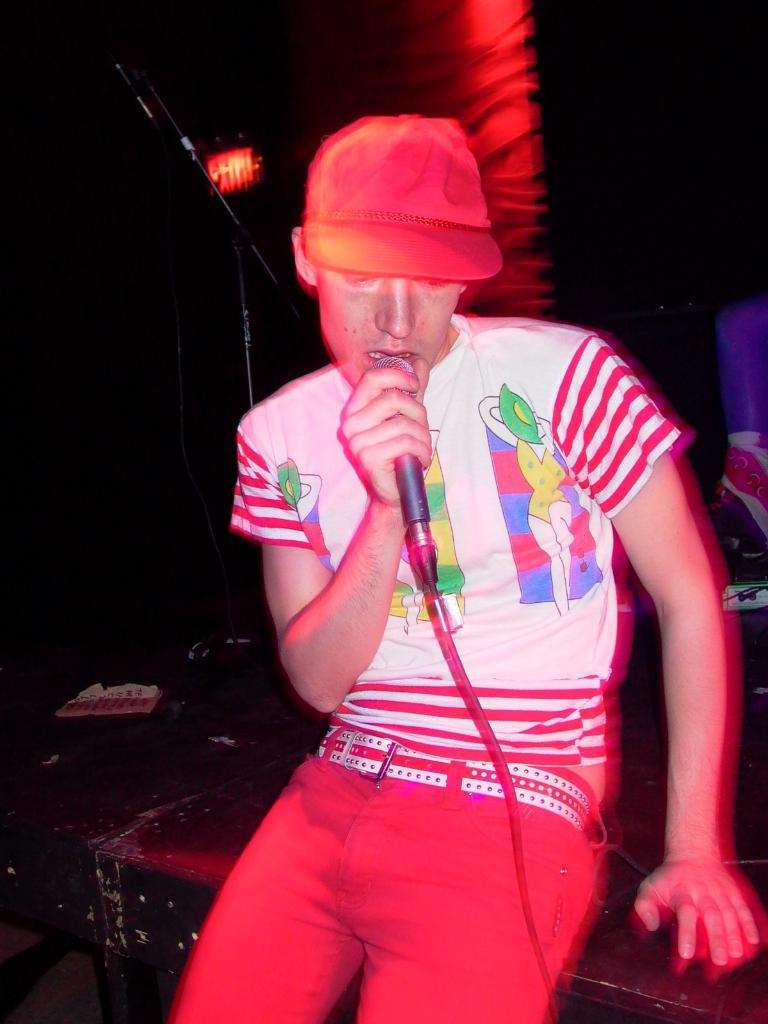Who is the main subject in the foreground of the image? There is a person in the foreground of the image. What is the person wearing on their head? The person is wearing a cap. What object is the person holding in their hand? The person is holding a microphone. How would you describe the lighting in the background of the image? The background of the image appears dark. What type of scene is taking place in the image involving a carriage and thunder? There is no scene involving a carriage and thunder present in the image; it features a person wearing a cap and holding a microphone against a dark background. 